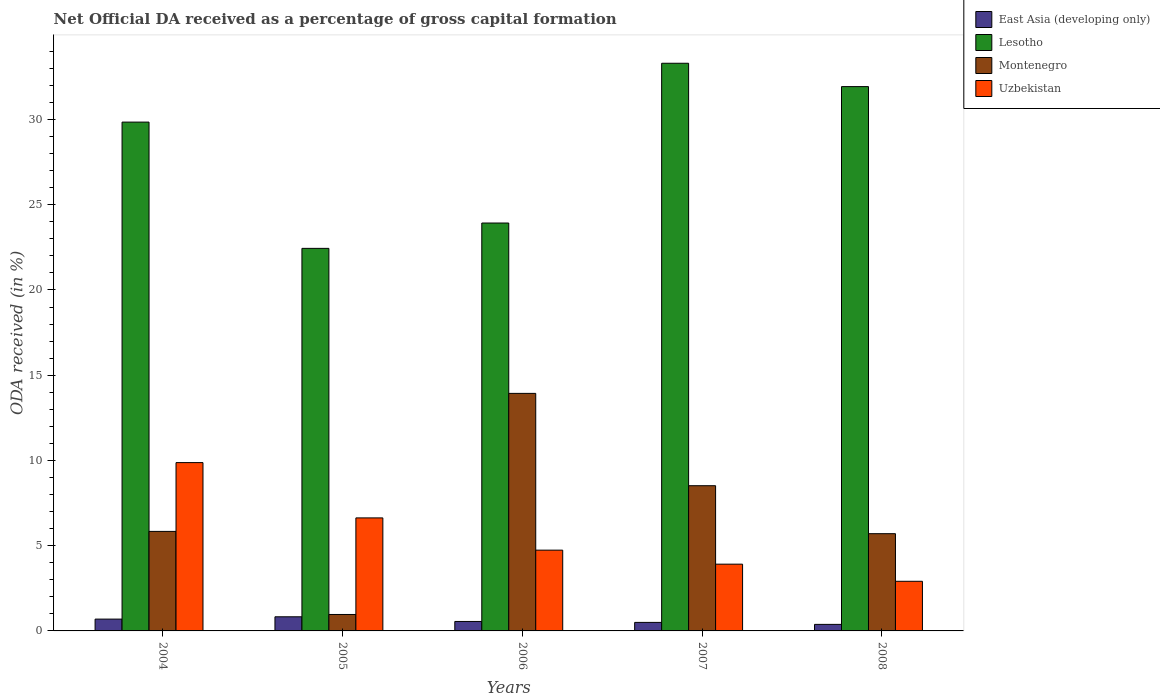How many groups of bars are there?
Provide a succinct answer. 5. Are the number of bars per tick equal to the number of legend labels?
Your response must be concise. Yes. How many bars are there on the 3rd tick from the left?
Provide a succinct answer. 4. What is the label of the 2nd group of bars from the left?
Provide a succinct answer. 2005. What is the net ODA received in Lesotho in 2007?
Give a very brief answer. 33.3. Across all years, what is the maximum net ODA received in Montenegro?
Offer a very short reply. 13.93. Across all years, what is the minimum net ODA received in Uzbekistan?
Keep it short and to the point. 2.91. What is the total net ODA received in Lesotho in the graph?
Your response must be concise. 141.45. What is the difference between the net ODA received in Montenegro in 2004 and that in 2007?
Your answer should be very brief. -2.68. What is the difference between the net ODA received in Montenegro in 2008 and the net ODA received in East Asia (developing only) in 2004?
Provide a succinct answer. 5.01. What is the average net ODA received in Montenegro per year?
Your answer should be compact. 6.99. In the year 2005, what is the difference between the net ODA received in East Asia (developing only) and net ODA received in Montenegro?
Offer a terse response. -0.14. In how many years, is the net ODA received in Uzbekistan greater than 7 %?
Offer a very short reply. 1. What is the ratio of the net ODA received in Montenegro in 2004 to that in 2005?
Provide a short and direct response. 6.05. Is the difference between the net ODA received in East Asia (developing only) in 2005 and 2007 greater than the difference between the net ODA received in Montenegro in 2005 and 2007?
Your answer should be compact. Yes. What is the difference between the highest and the second highest net ODA received in Uzbekistan?
Make the answer very short. 3.24. What is the difference between the highest and the lowest net ODA received in Lesotho?
Offer a terse response. 10.86. In how many years, is the net ODA received in East Asia (developing only) greater than the average net ODA received in East Asia (developing only) taken over all years?
Your answer should be compact. 2. Is the sum of the net ODA received in East Asia (developing only) in 2007 and 2008 greater than the maximum net ODA received in Montenegro across all years?
Make the answer very short. No. What does the 4th bar from the left in 2005 represents?
Your answer should be very brief. Uzbekistan. What does the 4th bar from the right in 2005 represents?
Ensure brevity in your answer.  East Asia (developing only). Are all the bars in the graph horizontal?
Your answer should be very brief. No. Where does the legend appear in the graph?
Give a very brief answer. Top right. What is the title of the graph?
Your answer should be compact. Net Official DA received as a percentage of gross capital formation. Does "American Samoa" appear as one of the legend labels in the graph?
Your response must be concise. No. What is the label or title of the X-axis?
Ensure brevity in your answer.  Years. What is the label or title of the Y-axis?
Provide a succinct answer. ODA received (in %). What is the ODA received (in %) of East Asia (developing only) in 2004?
Make the answer very short. 0.69. What is the ODA received (in %) of Lesotho in 2004?
Offer a terse response. 29.85. What is the ODA received (in %) of Montenegro in 2004?
Offer a terse response. 5.84. What is the ODA received (in %) of Uzbekistan in 2004?
Ensure brevity in your answer.  9.87. What is the ODA received (in %) in East Asia (developing only) in 2005?
Give a very brief answer. 0.83. What is the ODA received (in %) of Lesotho in 2005?
Offer a terse response. 22.44. What is the ODA received (in %) in Montenegro in 2005?
Ensure brevity in your answer.  0.96. What is the ODA received (in %) of Uzbekistan in 2005?
Make the answer very short. 6.63. What is the ODA received (in %) in East Asia (developing only) in 2006?
Ensure brevity in your answer.  0.55. What is the ODA received (in %) of Lesotho in 2006?
Your response must be concise. 23.93. What is the ODA received (in %) of Montenegro in 2006?
Your answer should be very brief. 13.93. What is the ODA received (in %) of Uzbekistan in 2006?
Your answer should be very brief. 4.74. What is the ODA received (in %) of East Asia (developing only) in 2007?
Keep it short and to the point. 0.5. What is the ODA received (in %) in Lesotho in 2007?
Your response must be concise. 33.3. What is the ODA received (in %) of Montenegro in 2007?
Give a very brief answer. 8.52. What is the ODA received (in %) of Uzbekistan in 2007?
Your answer should be compact. 3.92. What is the ODA received (in %) in East Asia (developing only) in 2008?
Your answer should be very brief. 0.38. What is the ODA received (in %) in Lesotho in 2008?
Your answer should be compact. 31.93. What is the ODA received (in %) of Montenegro in 2008?
Give a very brief answer. 5.7. What is the ODA received (in %) of Uzbekistan in 2008?
Keep it short and to the point. 2.91. Across all years, what is the maximum ODA received (in %) of East Asia (developing only)?
Provide a short and direct response. 0.83. Across all years, what is the maximum ODA received (in %) of Lesotho?
Your response must be concise. 33.3. Across all years, what is the maximum ODA received (in %) of Montenegro?
Provide a short and direct response. 13.93. Across all years, what is the maximum ODA received (in %) of Uzbekistan?
Give a very brief answer. 9.87. Across all years, what is the minimum ODA received (in %) of East Asia (developing only)?
Your answer should be very brief. 0.38. Across all years, what is the minimum ODA received (in %) in Lesotho?
Keep it short and to the point. 22.44. Across all years, what is the minimum ODA received (in %) in Montenegro?
Your answer should be compact. 0.96. Across all years, what is the minimum ODA received (in %) in Uzbekistan?
Provide a short and direct response. 2.91. What is the total ODA received (in %) in East Asia (developing only) in the graph?
Offer a very short reply. 2.96. What is the total ODA received (in %) of Lesotho in the graph?
Your answer should be very brief. 141.45. What is the total ODA received (in %) of Montenegro in the graph?
Offer a very short reply. 34.96. What is the total ODA received (in %) of Uzbekistan in the graph?
Offer a terse response. 28.07. What is the difference between the ODA received (in %) of East Asia (developing only) in 2004 and that in 2005?
Give a very brief answer. -0.14. What is the difference between the ODA received (in %) of Lesotho in 2004 and that in 2005?
Offer a terse response. 7.41. What is the difference between the ODA received (in %) in Montenegro in 2004 and that in 2005?
Your answer should be compact. 4.87. What is the difference between the ODA received (in %) of Uzbekistan in 2004 and that in 2005?
Offer a very short reply. 3.24. What is the difference between the ODA received (in %) in East Asia (developing only) in 2004 and that in 2006?
Ensure brevity in your answer.  0.14. What is the difference between the ODA received (in %) in Lesotho in 2004 and that in 2006?
Keep it short and to the point. 5.92. What is the difference between the ODA received (in %) in Montenegro in 2004 and that in 2006?
Provide a short and direct response. -8.1. What is the difference between the ODA received (in %) in Uzbekistan in 2004 and that in 2006?
Ensure brevity in your answer.  5.14. What is the difference between the ODA received (in %) in East Asia (developing only) in 2004 and that in 2007?
Ensure brevity in your answer.  0.19. What is the difference between the ODA received (in %) of Lesotho in 2004 and that in 2007?
Keep it short and to the point. -3.45. What is the difference between the ODA received (in %) of Montenegro in 2004 and that in 2007?
Your answer should be very brief. -2.68. What is the difference between the ODA received (in %) of Uzbekistan in 2004 and that in 2007?
Your answer should be compact. 5.96. What is the difference between the ODA received (in %) of East Asia (developing only) in 2004 and that in 2008?
Your response must be concise. 0.31. What is the difference between the ODA received (in %) of Lesotho in 2004 and that in 2008?
Your answer should be very brief. -2.08. What is the difference between the ODA received (in %) of Montenegro in 2004 and that in 2008?
Provide a succinct answer. 0.13. What is the difference between the ODA received (in %) in Uzbekistan in 2004 and that in 2008?
Give a very brief answer. 6.96. What is the difference between the ODA received (in %) in East Asia (developing only) in 2005 and that in 2006?
Provide a succinct answer. 0.27. What is the difference between the ODA received (in %) of Lesotho in 2005 and that in 2006?
Offer a terse response. -1.49. What is the difference between the ODA received (in %) of Montenegro in 2005 and that in 2006?
Your answer should be compact. -12.97. What is the difference between the ODA received (in %) of Uzbekistan in 2005 and that in 2006?
Give a very brief answer. 1.89. What is the difference between the ODA received (in %) of East Asia (developing only) in 2005 and that in 2007?
Provide a succinct answer. 0.33. What is the difference between the ODA received (in %) of Lesotho in 2005 and that in 2007?
Offer a terse response. -10.86. What is the difference between the ODA received (in %) in Montenegro in 2005 and that in 2007?
Provide a succinct answer. -7.55. What is the difference between the ODA received (in %) of Uzbekistan in 2005 and that in 2007?
Offer a very short reply. 2.71. What is the difference between the ODA received (in %) in East Asia (developing only) in 2005 and that in 2008?
Provide a short and direct response. 0.45. What is the difference between the ODA received (in %) of Lesotho in 2005 and that in 2008?
Your answer should be very brief. -9.49. What is the difference between the ODA received (in %) in Montenegro in 2005 and that in 2008?
Provide a short and direct response. -4.74. What is the difference between the ODA received (in %) of Uzbekistan in 2005 and that in 2008?
Give a very brief answer. 3.72. What is the difference between the ODA received (in %) of East Asia (developing only) in 2006 and that in 2007?
Your response must be concise. 0.05. What is the difference between the ODA received (in %) in Lesotho in 2006 and that in 2007?
Provide a short and direct response. -9.37. What is the difference between the ODA received (in %) of Montenegro in 2006 and that in 2007?
Keep it short and to the point. 5.42. What is the difference between the ODA received (in %) in Uzbekistan in 2006 and that in 2007?
Keep it short and to the point. 0.82. What is the difference between the ODA received (in %) of East Asia (developing only) in 2006 and that in 2008?
Provide a succinct answer. 0.17. What is the difference between the ODA received (in %) in Lesotho in 2006 and that in 2008?
Ensure brevity in your answer.  -8. What is the difference between the ODA received (in %) of Montenegro in 2006 and that in 2008?
Ensure brevity in your answer.  8.23. What is the difference between the ODA received (in %) in Uzbekistan in 2006 and that in 2008?
Provide a succinct answer. 1.83. What is the difference between the ODA received (in %) of East Asia (developing only) in 2007 and that in 2008?
Your answer should be very brief. 0.12. What is the difference between the ODA received (in %) in Lesotho in 2007 and that in 2008?
Your response must be concise. 1.37. What is the difference between the ODA received (in %) of Montenegro in 2007 and that in 2008?
Make the answer very short. 2.81. What is the difference between the ODA received (in %) in Uzbekistan in 2007 and that in 2008?
Your answer should be very brief. 1. What is the difference between the ODA received (in %) in East Asia (developing only) in 2004 and the ODA received (in %) in Lesotho in 2005?
Offer a very short reply. -21.75. What is the difference between the ODA received (in %) of East Asia (developing only) in 2004 and the ODA received (in %) of Montenegro in 2005?
Make the answer very short. -0.27. What is the difference between the ODA received (in %) of East Asia (developing only) in 2004 and the ODA received (in %) of Uzbekistan in 2005?
Offer a very short reply. -5.94. What is the difference between the ODA received (in %) in Lesotho in 2004 and the ODA received (in %) in Montenegro in 2005?
Your answer should be compact. 28.88. What is the difference between the ODA received (in %) in Lesotho in 2004 and the ODA received (in %) in Uzbekistan in 2005?
Give a very brief answer. 23.22. What is the difference between the ODA received (in %) of Montenegro in 2004 and the ODA received (in %) of Uzbekistan in 2005?
Your answer should be compact. -0.79. What is the difference between the ODA received (in %) in East Asia (developing only) in 2004 and the ODA received (in %) in Lesotho in 2006?
Your answer should be very brief. -23.23. What is the difference between the ODA received (in %) of East Asia (developing only) in 2004 and the ODA received (in %) of Montenegro in 2006?
Keep it short and to the point. -13.24. What is the difference between the ODA received (in %) of East Asia (developing only) in 2004 and the ODA received (in %) of Uzbekistan in 2006?
Your response must be concise. -4.05. What is the difference between the ODA received (in %) in Lesotho in 2004 and the ODA received (in %) in Montenegro in 2006?
Give a very brief answer. 15.91. What is the difference between the ODA received (in %) of Lesotho in 2004 and the ODA received (in %) of Uzbekistan in 2006?
Your answer should be very brief. 25.11. What is the difference between the ODA received (in %) of Montenegro in 2004 and the ODA received (in %) of Uzbekistan in 2006?
Offer a terse response. 1.1. What is the difference between the ODA received (in %) of East Asia (developing only) in 2004 and the ODA received (in %) of Lesotho in 2007?
Keep it short and to the point. -32.61. What is the difference between the ODA received (in %) of East Asia (developing only) in 2004 and the ODA received (in %) of Montenegro in 2007?
Ensure brevity in your answer.  -7.82. What is the difference between the ODA received (in %) of East Asia (developing only) in 2004 and the ODA received (in %) of Uzbekistan in 2007?
Make the answer very short. -3.22. What is the difference between the ODA received (in %) of Lesotho in 2004 and the ODA received (in %) of Montenegro in 2007?
Make the answer very short. 21.33. What is the difference between the ODA received (in %) in Lesotho in 2004 and the ODA received (in %) in Uzbekistan in 2007?
Make the answer very short. 25.93. What is the difference between the ODA received (in %) of Montenegro in 2004 and the ODA received (in %) of Uzbekistan in 2007?
Offer a terse response. 1.92. What is the difference between the ODA received (in %) in East Asia (developing only) in 2004 and the ODA received (in %) in Lesotho in 2008?
Provide a succinct answer. -31.24. What is the difference between the ODA received (in %) of East Asia (developing only) in 2004 and the ODA received (in %) of Montenegro in 2008?
Provide a succinct answer. -5.01. What is the difference between the ODA received (in %) of East Asia (developing only) in 2004 and the ODA received (in %) of Uzbekistan in 2008?
Provide a succinct answer. -2.22. What is the difference between the ODA received (in %) of Lesotho in 2004 and the ODA received (in %) of Montenegro in 2008?
Provide a short and direct response. 24.14. What is the difference between the ODA received (in %) in Lesotho in 2004 and the ODA received (in %) in Uzbekistan in 2008?
Offer a very short reply. 26.94. What is the difference between the ODA received (in %) in Montenegro in 2004 and the ODA received (in %) in Uzbekistan in 2008?
Keep it short and to the point. 2.93. What is the difference between the ODA received (in %) of East Asia (developing only) in 2005 and the ODA received (in %) of Lesotho in 2006?
Your answer should be compact. -23.1. What is the difference between the ODA received (in %) of East Asia (developing only) in 2005 and the ODA received (in %) of Montenegro in 2006?
Provide a short and direct response. -13.11. What is the difference between the ODA received (in %) in East Asia (developing only) in 2005 and the ODA received (in %) in Uzbekistan in 2006?
Offer a terse response. -3.91. What is the difference between the ODA received (in %) in Lesotho in 2005 and the ODA received (in %) in Montenegro in 2006?
Provide a short and direct response. 8.51. What is the difference between the ODA received (in %) of Lesotho in 2005 and the ODA received (in %) of Uzbekistan in 2006?
Your answer should be very brief. 17.7. What is the difference between the ODA received (in %) of Montenegro in 2005 and the ODA received (in %) of Uzbekistan in 2006?
Give a very brief answer. -3.77. What is the difference between the ODA received (in %) of East Asia (developing only) in 2005 and the ODA received (in %) of Lesotho in 2007?
Ensure brevity in your answer.  -32.47. What is the difference between the ODA received (in %) in East Asia (developing only) in 2005 and the ODA received (in %) in Montenegro in 2007?
Offer a very short reply. -7.69. What is the difference between the ODA received (in %) of East Asia (developing only) in 2005 and the ODA received (in %) of Uzbekistan in 2007?
Your answer should be very brief. -3.09. What is the difference between the ODA received (in %) in Lesotho in 2005 and the ODA received (in %) in Montenegro in 2007?
Provide a succinct answer. 13.92. What is the difference between the ODA received (in %) of Lesotho in 2005 and the ODA received (in %) of Uzbekistan in 2007?
Your answer should be very brief. 18.53. What is the difference between the ODA received (in %) in Montenegro in 2005 and the ODA received (in %) in Uzbekistan in 2007?
Offer a terse response. -2.95. What is the difference between the ODA received (in %) in East Asia (developing only) in 2005 and the ODA received (in %) in Lesotho in 2008?
Provide a short and direct response. -31.1. What is the difference between the ODA received (in %) in East Asia (developing only) in 2005 and the ODA received (in %) in Montenegro in 2008?
Provide a succinct answer. -4.88. What is the difference between the ODA received (in %) in East Asia (developing only) in 2005 and the ODA received (in %) in Uzbekistan in 2008?
Ensure brevity in your answer.  -2.08. What is the difference between the ODA received (in %) in Lesotho in 2005 and the ODA received (in %) in Montenegro in 2008?
Offer a terse response. 16.74. What is the difference between the ODA received (in %) of Lesotho in 2005 and the ODA received (in %) of Uzbekistan in 2008?
Ensure brevity in your answer.  19.53. What is the difference between the ODA received (in %) of Montenegro in 2005 and the ODA received (in %) of Uzbekistan in 2008?
Give a very brief answer. -1.95. What is the difference between the ODA received (in %) of East Asia (developing only) in 2006 and the ODA received (in %) of Lesotho in 2007?
Offer a terse response. -32.75. What is the difference between the ODA received (in %) in East Asia (developing only) in 2006 and the ODA received (in %) in Montenegro in 2007?
Your answer should be very brief. -7.96. What is the difference between the ODA received (in %) in East Asia (developing only) in 2006 and the ODA received (in %) in Uzbekistan in 2007?
Your response must be concise. -3.36. What is the difference between the ODA received (in %) of Lesotho in 2006 and the ODA received (in %) of Montenegro in 2007?
Provide a succinct answer. 15.41. What is the difference between the ODA received (in %) of Lesotho in 2006 and the ODA received (in %) of Uzbekistan in 2007?
Provide a succinct answer. 20.01. What is the difference between the ODA received (in %) of Montenegro in 2006 and the ODA received (in %) of Uzbekistan in 2007?
Your answer should be very brief. 10.02. What is the difference between the ODA received (in %) of East Asia (developing only) in 2006 and the ODA received (in %) of Lesotho in 2008?
Offer a terse response. -31.38. What is the difference between the ODA received (in %) of East Asia (developing only) in 2006 and the ODA received (in %) of Montenegro in 2008?
Provide a succinct answer. -5.15. What is the difference between the ODA received (in %) of East Asia (developing only) in 2006 and the ODA received (in %) of Uzbekistan in 2008?
Offer a terse response. -2.36. What is the difference between the ODA received (in %) in Lesotho in 2006 and the ODA received (in %) in Montenegro in 2008?
Give a very brief answer. 18.22. What is the difference between the ODA received (in %) of Lesotho in 2006 and the ODA received (in %) of Uzbekistan in 2008?
Provide a succinct answer. 21.02. What is the difference between the ODA received (in %) of Montenegro in 2006 and the ODA received (in %) of Uzbekistan in 2008?
Keep it short and to the point. 11.02. What is the difference between the ODA received (in %) of East Asia (developing only) in 2007 and the ODA received (in %) of Lesotho in 2008?
Your answer should be compact. -31.43. What is the difference between the ODA received (in %) of East Asia (developing only) in 2007 and the ODA received (in %) of Montenegro in 2008?
Keep it short and to the point. -5.2. What is the difference between the ODA received (in %) in East Asia (developing only) in 2007 and the ODA received (in %) in Uzbekistan in 2008?
Your answer should be very brief. -2.41. What is the difference between the ODA received (in %) in Lesotho in 2007 and the ODA received (in %) in Montenegro in 2008?
Keep it short and to the point. 27.6. What is the difference between the ODA received (in %) of Lesotho in 2007 and the ODA received (in %) of Uzbekistan in 2008?
Provide a succinct answer. 30.39. What is the difference between the ODA received (in %) of Montenegro in 2007 and the ODA received (in %) of Uzbekistan in 2008?
Provide a succinct answer. 5.61. What is the average ODA received (in %) of East Asia (developing only) per year?
Your answer should be very brief. 0.59. What is the average ODA received (in %) of Lesotho per year?
Ensure brevity in your answer.  28.29. What is the average ODA received (in %) in Montenegro per year?
Your answer should be very brief. 6.99. What is the average ODA received (in %) of Uzbekistan per year?
Offer a terse response. 5.61. In the year 2004, what is the difference between the ODA received (in %) in East Asia (developing only) and ODA received (in %) in Lesotho?
Your response must be concise. -29.15. In the year 2004, what is the difference between the ODA received (in %) of East Asia (developing only) and ODA received (in %) of Montenegro?
Provide a succinct answer. -5.14. In the year 2004, what is the difference between the ODA received (in %) in East Asia (developing only) and ODA received (in %) in Uzbekistan?
Offer a very short reply. -9.18. In the year 2004, what is the difference between the ODA received (in %) of Lesotho and ODA received (in %) of Montenegro?
Provide a succinct answer. 24.01. In the year 2004, what is the difference between the ODA received (in %) of Lesotho and ODA received (in %) of Uzbekistan?
Make the answer very short. 19.97. In the year 2004, what is the difference between the ODA received (in %) in Montenegro and ODA received (in %) in Uzbekistan?
Give a very brief answer. -4.04. In the year 2005, what is the difference between the ODA received (in %) in East Asia (developing only) and ODA received (in %) in Lesotho?
Your answer should be compact. -21.61. In the year 2005, what is the difference between the ODA received (in %) of East Asia (developing only) and ODA received (in %) of Montenegro?
Your response must be concise. -0.14. In the year 2005, what is the difference between the ODA received (in %) in East Asia (developing only) and ODA received (in %) in Uzbekistan?
Your answer should be very brief. -5.8. In the year 2005, what is the difference between the ODA received (in %) in Lesotho and ODA received (in %) in Montenegro?
Offer a terse response. 21.48. In the year 2005, what is the difference between the ODA received (in %) in Lesotho and ODA received (in %) in Uzbekistan?
Provide a succinct answer. 15.81. In the year 2005, what is the difference between the ODA received (in %) in Montenegro and ODA received (in %) in Uzbekistan?
Provide a short and direct response. -5.67. In the year 2006, what is the difference between the ODA received (in %) of East Asia (developing only) and ODA received (in %) of Lesotho?
Keep it short and to the point. -23.37. In the year 2006, what is the difference between the ODA received (in %) of East Asia (developing only) and ODA received (in %) of Montenegro?
Make the answer very short. -13.38. In the year 2006, what is the difference between the ODA received (in %) in East Asia (developing only) and ODA received (in %) in Uzbekistan?
Give a very brief answer. -4.18. In the year 2006, what is the difference between the ODA received (in %) in Lesotho and ODA received (in %) in Montenegro?
Your answer should be very brief. 9.99. In the year 2006, what is the difference between the ODA received (in %) in Lesotho and ODA received (in %) in Uzbekistan?
Your response must be concise. 19.19. In the year 2006, what is the difference between the ODA received (in %) in Montenegro and ODA received (in %) in Uzbekistan?
Your answer should be compact. 9.2. In the year 2007, what is the difference between the ODA received (in %) of East Asia (developing only) and ODA received (in %) of Lesotho?
Make the answer very short. -32.8. In the year 2007, what is the difference between the ODA received (in %) of East Asia (developing only) and ODA received (in %) of Montenegro?
Your answer should be very brief. -8.02. In the year 2007, what is the difference between the ODA received (in %) in East Asia (developing only) and ODA received (in %) in Uzbekistan?
Your response must be concise. -3.42. In the year 2007, what is the difference between the ODA received (in %) of Lesotho and ODA received (in %) of Montenegro?
Ensure brevity in your answer.  24.78. In the year 2007, what is the difference between the ODA received (in %) in Lesotho and ODA received (in %) in Uzbekistan?
Provide a short and direct response. 29.38. In the year 2007, what is the difference between the ODA received (in %) of Montenegro and ODA received (in %) of Uzbekistan?
Keep it short and to the point. 4.6. In the year 2008, what is the difference between the ODA received (in %) in East Asia (developing only) and ODA received (in %) in Lesotho?
Ensure brevity in your answer.  -31.55. In the year 2008, what is the difference between the ODA received (in %) of East Asia (developing only) and ODA received (in %) of Montenegro?
Give a very brief answer. -5.32. In the year 2008, what is the difference between the ODA received (in %) of East Asia (developing only) and ODA received (in %) of Uzbekistan?
Offer a terse response. -2.53. In the year 2008, what is the difference between the ODA received (in %) in Lesotho and ODA received (in %) in Montenegro?
Ensure brevity in your answer.  26.23. In the year 2008, what is the difference between the ODA received (in %) in Lesotho and ODA received (in %) in Uzbekistan?
Your answer should be very brief. 29.02. In the year 2008, what is the difference between the ODA received (in %) in Montenegro and ODA received (in %) in Uzbekistan?
Make the answer very short. 2.79. What is the ratio of the ODA received (in %) of East Asia (developing only) in 2004 to that in 2005?
Your answer should be compact. 0.84. What is the ratio of the ODA received (in %) of Lesotho in 2004 to that in 2005?
Give a very brief answer. 1.33. What is the ratio of the ODA received (in %) in Montenegro in 2004 to that in 2005?
Provide a short and direct response. 6.05. What is the ratio of the ODA received (in %) of Uzbekistan in 2004 to that in 2005?
Your answer should be compact. 1.49. What is the ratio of the ODA received (in %) in East Asia (developing only) in 2004 to that in 2006?
Provide a short and direct response. 1.25. What is the ratio of the ODA received (in %) of Lesotho in 2004 to that in 2006?
Keep it short and to the point. 1.25. What is the ratio of the ODA received (in %) of Montenegro in 2004 to that in 2006?
Offer a very short reply. 0.42. What is the ratio of the ODA received (in %) of Uzbekistan in 2004 to that in 2006?
Give a very brief answer. 2.08. What is the ratio of the ODA received (in %) of East Asia (developing only) in 2004 to that in 2007?
Keep it short and to the point. 1.39. What is the ratio of the ODA received (in %) of Lesotho in 2004 to that in 2007?
Provide a short and direct response. 0.9. What is the ratio of the ODA received (in %) in Montenegro in 2004 to that in 2007?
Your answer should be compact. 0.69. What is the ratio of the ODA received (in %) of Uzbekistan in 2004 to that in 2007?
Ensure brevity in your answer.  2.52. What is the ratio of the ODA received (in %) of East Asia (developing only) in 2004 to that in 2008?
Provide a short and direct response. 1.81. What is the ratio of the ODA received (in %) of Lesotho in 2004 to that in 2008?
Keep it short and to the point. 0.93. What is the ratio of the ODA received (in %) in Montenegro in 2004 to that in 2008?
Provide a succinct answer. 1.02. What is the ratio of the ODA received (in %) of Uzbekistan in 2004 to that in 2008?
Your answer should be compact. 3.39. What is the ratio of the ODA received (in %) in East Asia (developing only) in 2005 to that in 2006?
Your answer should be compact. 1.5. What is the ratio of the ODA received (in %) of Lesotho in 2005 to that in 2006?
Your response must be concise. 0.94. What is the ratio of the ODA received (in %) of Montenegro in 2005 to that in 2006?
Ensure brevity in your answer.  0.07. What is the ratio of the ODA received (in %) in Uzbekistan in 2005 to that in 2006?
Make the answer very short. 1.4. What is the ratio of the ODA received (in %) of East Asia (developing only) in 2005 to that in 2007?
Your response must be concise. 1.66. What is the ratio of the ODA received (in %) in Lesotho in 2005 to that in 2007?
Keep it short and to the point. 0.67. What is the ratio of the ODA received (in %) of Montenegro in 2005 to that in 2007?
Give a very brief answer. 0.11. What is the ratio of the ODA received (in %) in Uzbekistan in 2005 to that in 2007?
Offer a very short reply. 1.69. What is the ratio of the ODA received (in %) of East Asia (developing only) in 2005 to that in 2008?
Give a very brief answer. 2.16. What is the ratio of the ODA received (in %) of Lesotho in 2005 to that in 2008?
Offer a very short reply. 0.7. What is the ratio of the ODA received (in %) of Montenegro in 2005 to that in 2008?
Your answer should be very brief. 0.17. What is the ratio of the ODA received (in %) of Uzbekistan in 2005 to that in 2008?
Offer a terse response. 2.28. What is the ratio of the ODA received (in %) in East Asia (developing only) in 2006 to that in 2007?
Give a very brief answer. 1.11. What is the ratio of the ODA received (in %) of Lesotho in 2006 to that in 2007?
Ensure brevity in your answer.  0.72. What is the ratio of the ODA received (in %) of Montenegro in 2006 to that in 2007?
Offer a very short reply. 1.64. What is the ratio of the ODA received (in %) in Uzbekistan in 2006 to that in 2007?
Give a very brief answer. 1.21. What is the ratio of the ODA received (in %) in East Asia (developing only) in 2006 to that in 2008?
Ensure brevity in your answer.  1.44. What is the ratio of the ODA received (in %) in Lesotho in 2006 to that in 2008?
Your answer should be very brief. 0.75. What is the ratio of the ODA received (in %) of Montenegro in 2006 to that in 2008?
Ensure brevity in your answer.  2.44. What is the ratio of the ODA received (in %) of Uzbekistan in 2006 to that in 2008?
Offer a very short reply. 1.63. What is the ratio of the ODA received (in %) in East Asia (developing only) in 2007 to that in 2008?
Your answer should be very brief. 1.3. What is the ratio of the ODA received (in %) in Lesotho in 2007 to that in 2008?
Offer a terse response. 1.04. What is the ratio of the ODA received (in %) in Montenegro in 2007 to that in 2008?
Offer a terse response. 1.49. What is the ratio of the ODA received (in %) of Uzbekistan in 2007 to that in 2008?
Your answer should be very brief. 1.34. What is the difference between the highest and the second highest ODA received (in %) of East Asia (developing only)?
Provide a short and direct response. 0.14. What is the difference between the highest and the second highest ODA received (in %) of Lesotho?
Offer a very short reply. 1.37. What is the difference between the highest and the second highest ODA received (in %) of Montenegro?
Provide a succinct answer. 5.42. What is the difference between the highest and the second highest ODA received (in %) in Uzbekistan?
Your answer should be very brief. 3.24. What is the difference between the highest and the lowest ODA received (in %) of East Asia (developing only)?
Your answer should be very brief. 0.45. What is the difference between the highest and the lowest ODA received (in %) in Lesotho?
Ensure brevity in your answer.  10.86. What is the difference between the highest and the lowest ODA received (in %) in Montenegro?
Ensure brevity in your answer.  12.97. What is the difference between the highest and the lowest ODA received (in %) in Uzbekistan?
Your answer should be very brief. 6.96. 